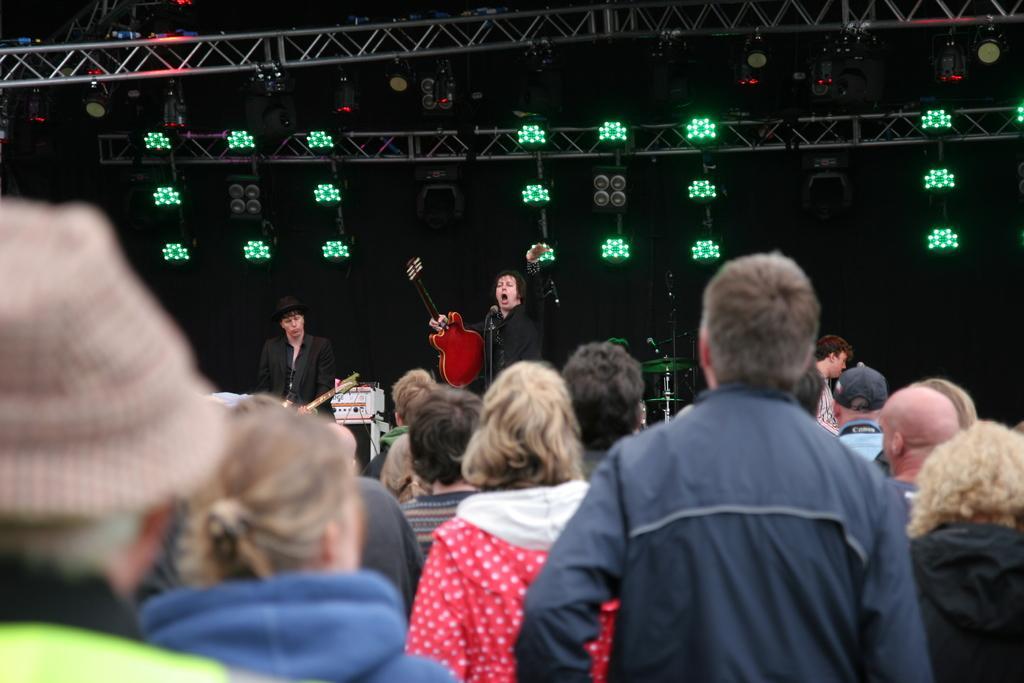In one or two sentences, can you explain what this image depicts? In this image I can see number of persons are standing and two persons wearing black dresses and holding musical instruments in their hands are standing on the stage. In the background I can see few musical instruments, few metal rods, few lights and the dark background. 